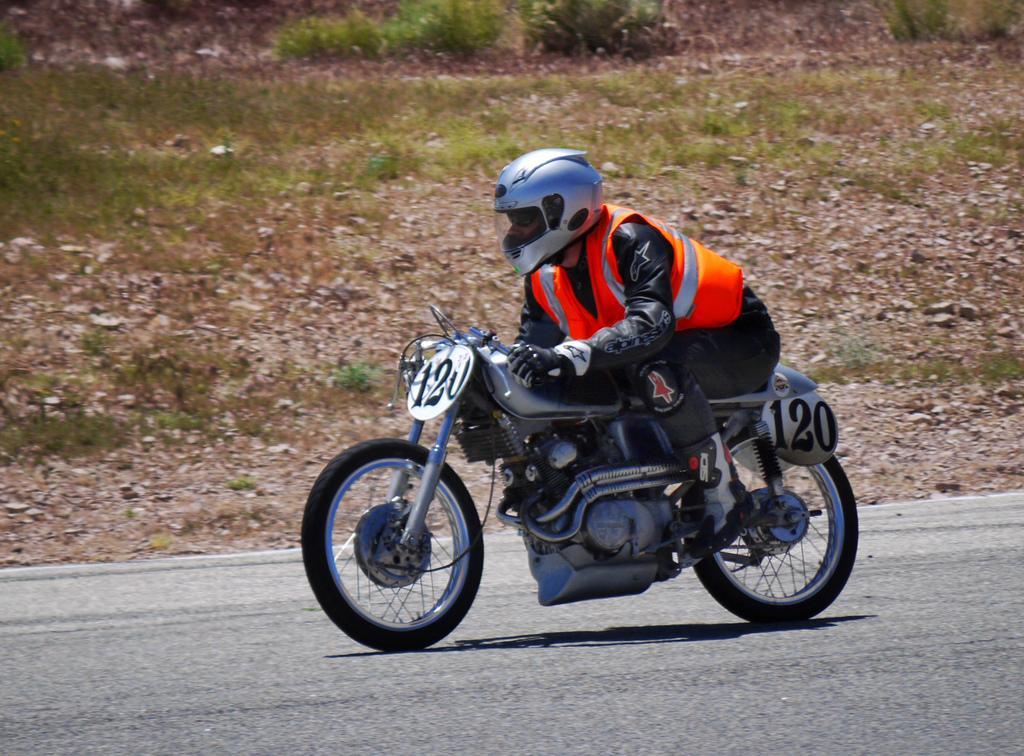Can you describe this image briefly? There is a person sitting and riding bike and wore helmet and we can see number boards on bike. In the background we can see grass and plants. 